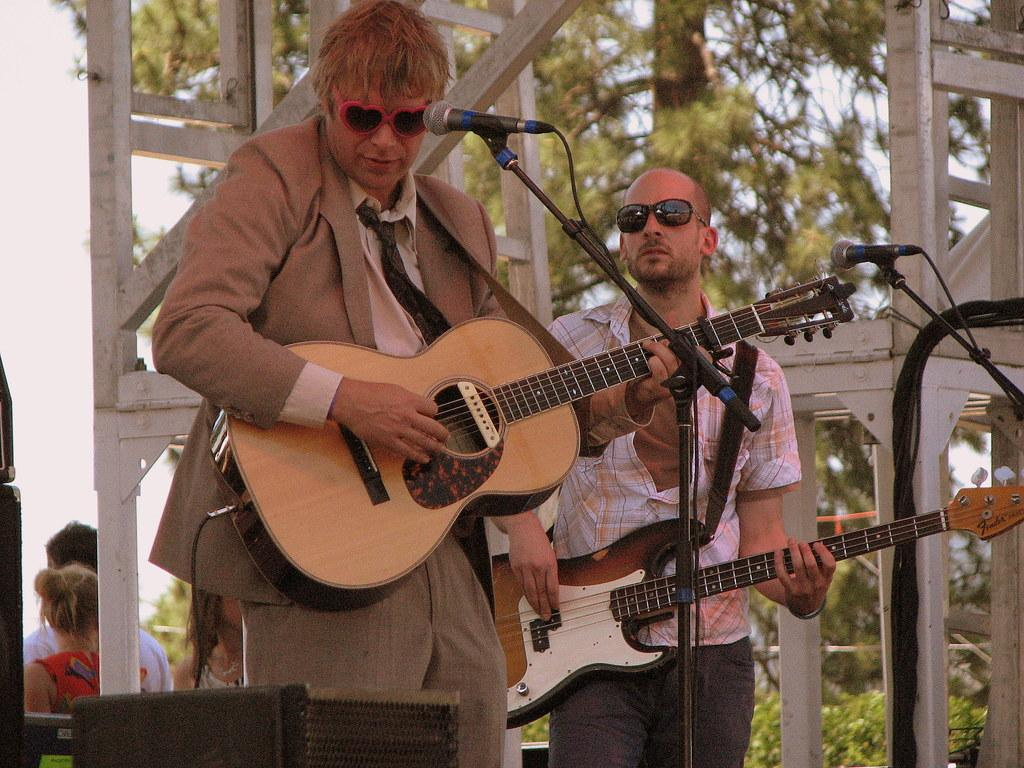How many people are in the image? There are two men in the image. What are the men doing in the image? The men are standing and playing guitars. What is in front of the men? There is a microphone stand in front of the men. What can be seen in the background of the image? There are trees and people in the background of the image. What time of day is it in the image, and how can you tell? The time of day cannot be determined from the image, as there are no clues or indicators of morning or any other time. Is there a washing machine present in the image? No, there is no washing machine present in the image. 